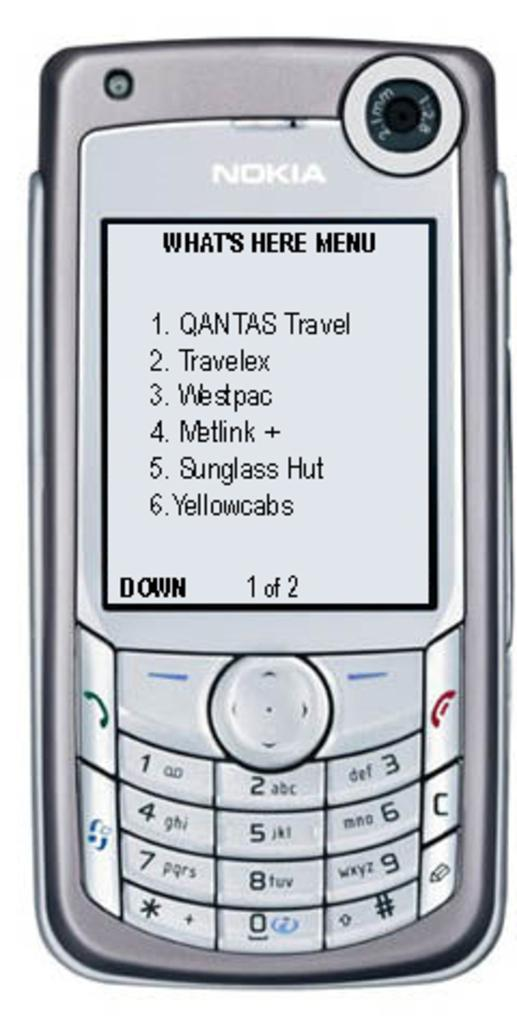<image>
Write a terse but informative summary of the picture. A Nokia cell phone is open to the "What's Here Menu." 